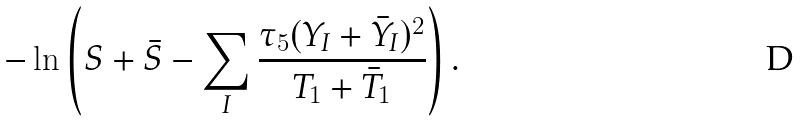<formula> <loc_0><loc_0><loc_500><loc_500>- \ln \left ( S + \bar { S } - \sum _ { I } \frac { \tau _ { 5 } ( Y _ { I } + \bar { Y } _ { I } ) ^ { 2 } } { T _ { 1 } + \bar { T } _ { 1 } } \right ) .</formula> 